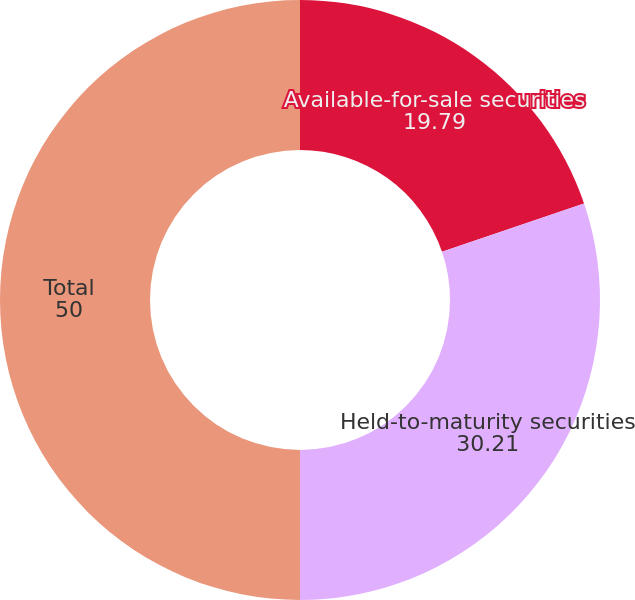Convert chart to OTSL. <chart><loc_0><loc_0><loc_500><loc_500><pie_chart><fcel>Available-for-sale securities<fcel>Held-to-maturity securities<fcel>Total<nl><fcel>19.79%<fcel>30.21%<fcel>50.0%<nl></chart> 